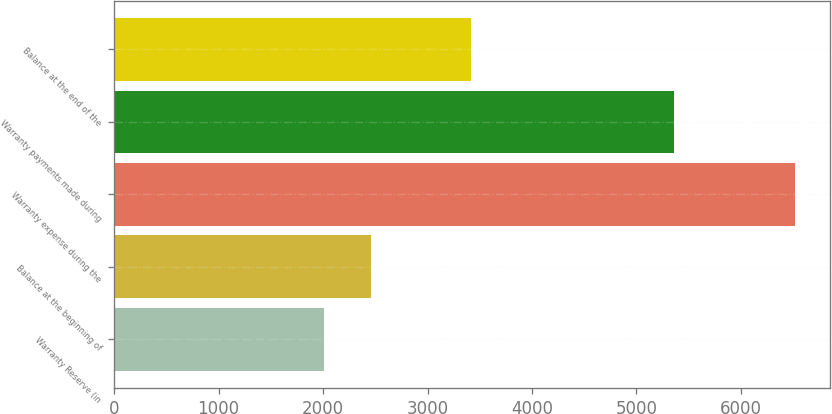<chart> <loc_0><loc_0><loc_500><loc_500><bar_chart><fcel>Warranty Reserve (in<fcel>Balance at the beginning of<fcel>Warranty expense during the<fcel>Warranty payments made during<fcel>Balance at the end of the<nl><fcel>2007<fcel>2458.5<fcel>6522<fcel>5361<fcel>3411<nl></chart> 